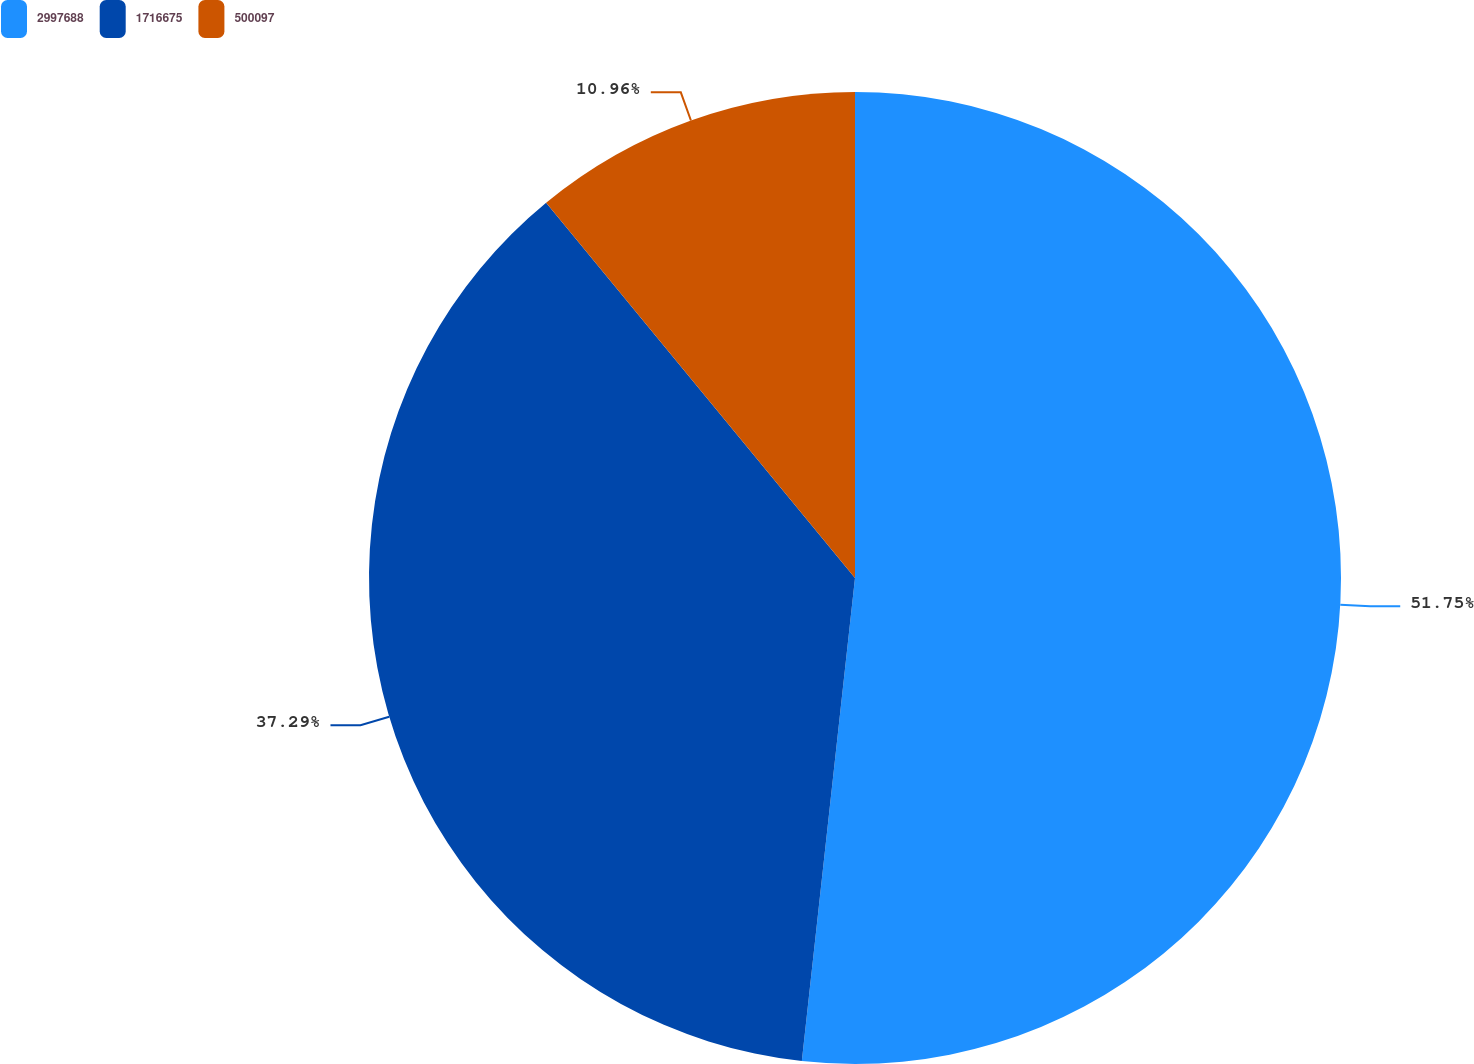Convert chart to OTSL. <chart><loc_0><loc_0><loc_500><loc_500><pie_chart><fcel>2997688<fcel>1716675<fcel>500097<nl><fcel>51.74%<fcel>37.29%<fcel>10.96%<nl></chart> 